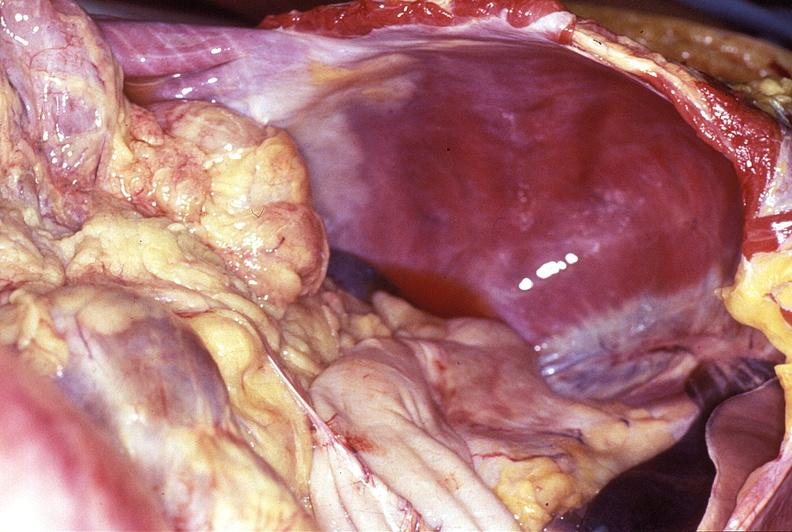what does this image show?
Answer the question using a single word or phrase. Intestine 